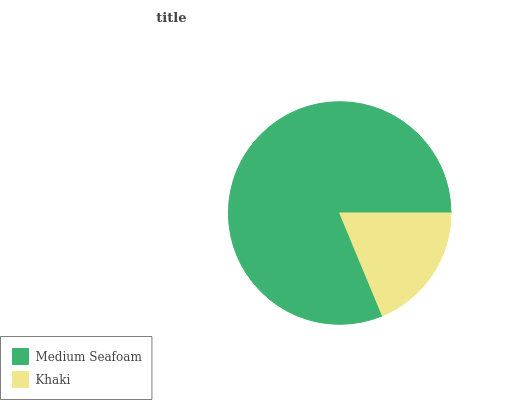Is Khaki the minimum?
Answer yes or no. Yes. Is Medium Seafoam the maximum?
Answer yes or no. Yes. Is Khaki the maximum?
Answer yes or no. No. Is Medium Seafoam greater than Khaki?
Answer yes or no. Yes. Is Khaki less than Medium Seafoam?
Answer yes or no. Yes. Is Khaki greater than Medium Seafoam?
Answer yes or no. No. Is Medium Seafoam less than Khaki?
Answer yes or no. No. Is Medium Seafoam the high median?
Answer yes or no. Yes. Is Khaki the low median?
Answer yes or no. Yes. Is Khaki the high median?
Answer yes or no. No. Is Medium Seafoam the low median?
Answer yes or no. No. 